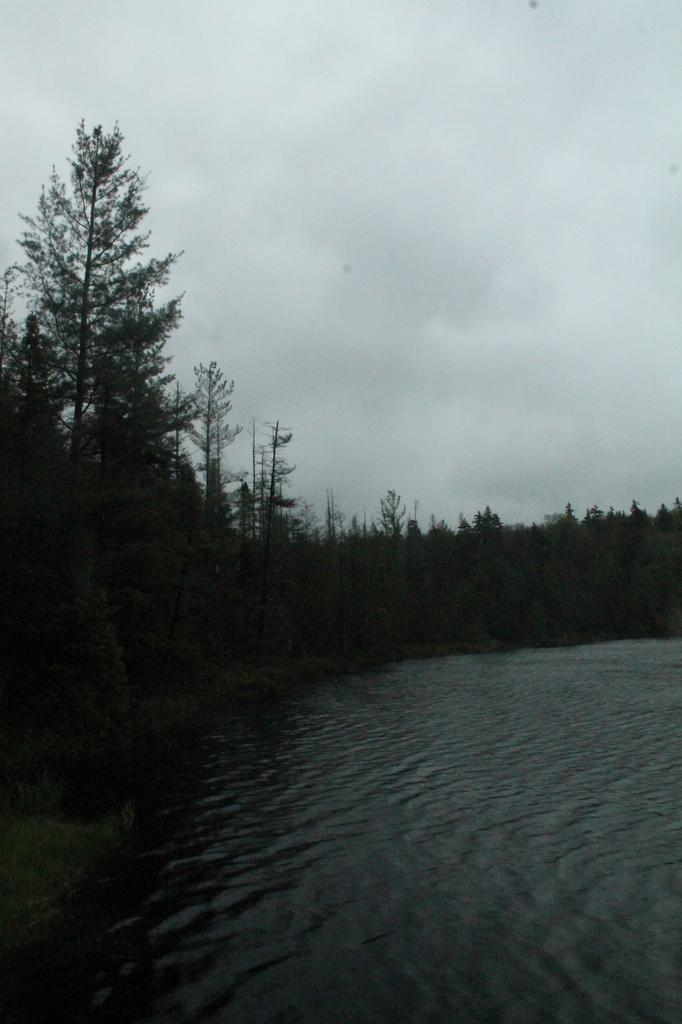What is visible in the image? Water, trees, and the sky are visible in the image. Can you describe the water in the image? The water is visible, but its specific characteristics are not mentioned in the facts. What is the background of the image? The sky is visible in the background of the image. What type of needle can be seen in the image? There is no needle present in the image. What form does the water take in the image? The facts do not specify the form of the water in the image, so we cannot definitively answer this question. 